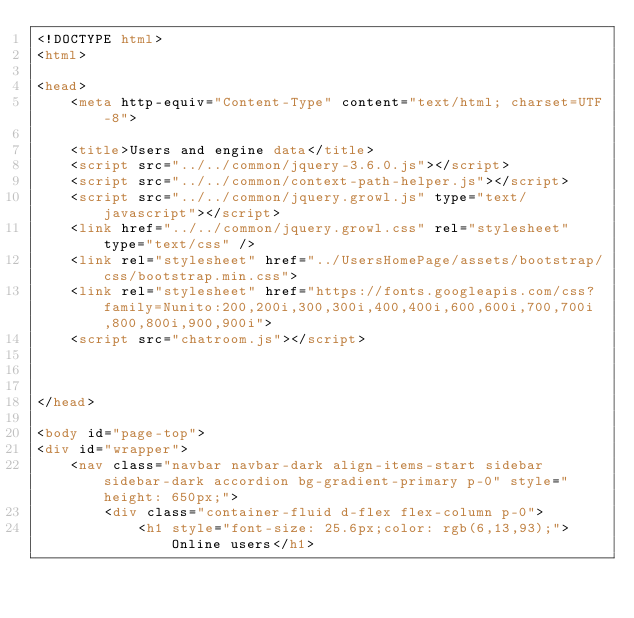<code> <loc_0><loc_0><loc_500><loc_500><_HTML_><!DOCTYPE html>
<html>

<head>
	<meta http-equiv="Content-Type" content="text/html; charset=UTF-8">

	<title>Users and engine data</title>
	<script src="../../common/jquery-3.6.0.js"></script>
	<script src="../../common/context-path-helper.js"></script>
	<script src="../../common/jquery.growl.js" type="text/javascript"></script>
	<link href="../../common/jquery.growl.css" rel="stylesheet" type="text/css" />
	<link rel="stylesheet" href="../UsersHomePage/assets/bootstrap/css/bootstrap.min.css">
	<link rel="stylesheet" href="https://fonts.googleapis.com/css?family=Nunito:200,200i,300,300i,400,400i,600,600i,700,700i,800,800i,900,900i">
	<script src="chatroom.js"></script>



</head>

<body id="page-top">
<div id="wrapper">
	<nav class="navbar navbar-dark align-items-start sidebar sidebar-dark accordion bg-gradient-primary p-0" style="height: 650px;">
		<div class="container-fluid d-flex flex-column p-0">
			<h1 style="font-size: 25.6px;color: rgb(6,13,93);">Online users</h1></code> 